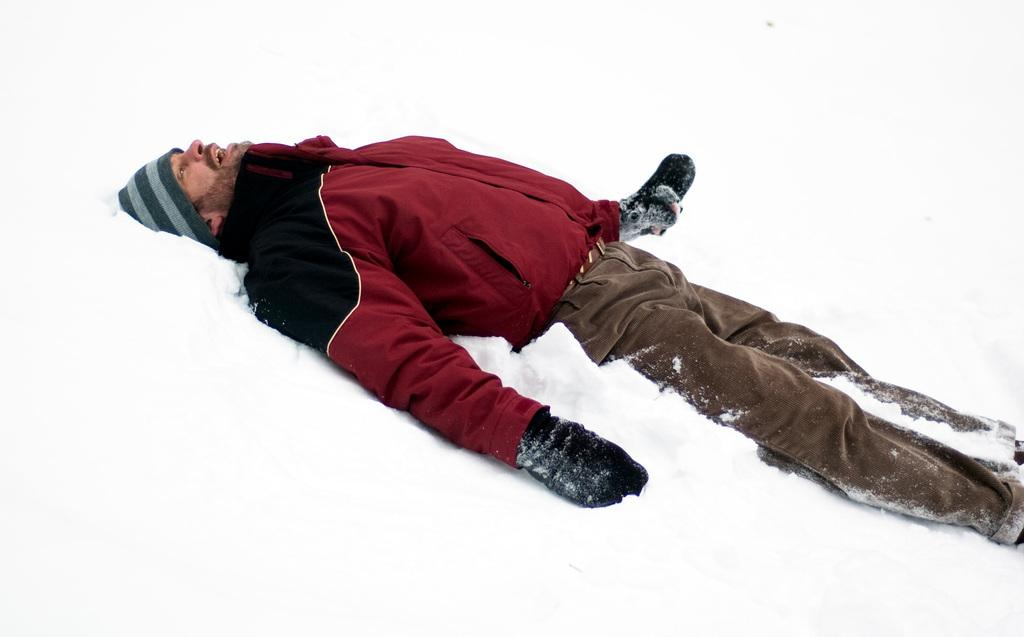Who is present in the image? There is a man in the image. What is the man doing in the image? The man is lying down. What is the man wearing on his head? The man is wearing a cap. What type of weather is depicted in the image? There is snow visible in the image. Can you see the man taking a walk in the snow in the image? The image does not show the man taking a walk; he is lying down. 